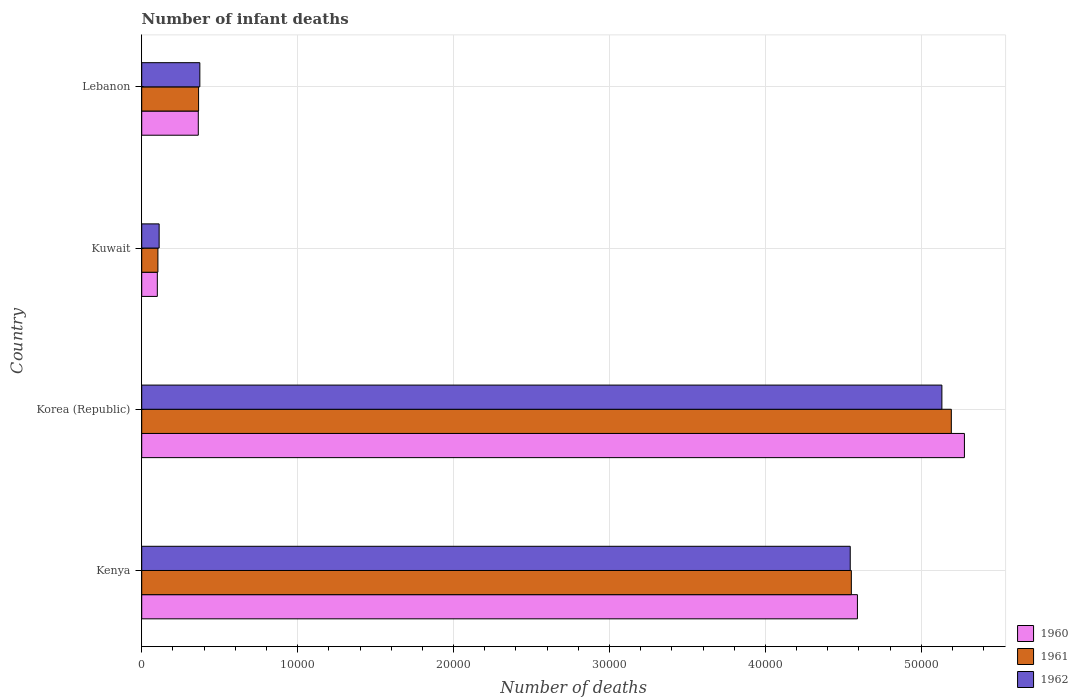How many bars are there on the 2nd tick from the bottom?
Offer a terse response. 3. What is the label of the 2nd group of bars from the top?
Make the answer very short. Kuwait. In how many cases, is the number of bars for a given country not equal to the number of legend labels?
Your answer should be compact. 0. What is the number of infant deaths in 1962 in Korea (Republic)?
Provide a short and direct response. 5.13e+04. Across all countries, what is the maximum number of infant deaths in 1960?
Your answer should be compact. 5.28e+04. Across all countries, what is the minimum number of infant deaths in 1962?
Offer a terse response. 1117. In which country was the number of infant deaths in 1962 minimum?
Give a very brief answer. Kuwait. What is the total number of infant deaths in 1962 in the graph?
Your response must be concise. 1.02e+05. What is the difference between the number of infant deaths in 1960 in Kenya and that in Kuwait?
Your answer should be very brief. 4.49e+04. What is the difference between the number of infant deaths in 1961 in Kuwait and the number of infant deaths in 1960 in Lebanon?
Keep it short and to the point. -2590. What is the average number of infant deaths in 1960 per country?
Make the answer very short. 2.58e+04. What is the difference between the number of infant deaths in 1960 and number of infant deaths in 1961 in Korea (Republic)?
Your answer should be very brief. 840. What is the ratio of the number of infant deaths in 1960 in Kuwait to that in Lebanon?
Provide a succinct answer. 0.28. What is the difference between the highest and the second highest number of infant deaths in 1960?
Provide a short and direct response. 6862. What is the difference between the highest and the lowest number of infant deaths in 1960?
Give a very brief answer. 5.18e+04. In how many countries, is the number of infant deaths in 1962 greater than the average number of infant deaths in 1962 taken over all countries?
Ensure brevity in your answer.  2. How many bars are there?
Keep it short and to the point. 12. How many countries are there in the graph?
Make the answer very short. 4. Are the values on the major ticks of X-axis written in scientific E-notation?
Make the answer very short. No. Does the graph contain grids?
Give a very brief answer. Yes. How are the legend labels stacked?
Offer a very short reply. Vertical. What is the title of the graph?
Provide a succinct answer. Number of infant deaths. What is the label or title of the X-axis?
Provide a succinct answer. Number of deaths. What is the Number of deaths in 1960 in Kenya?
Offer a very short reply. 4.59e+04. What is the Number of deaths of 1961 in Kenya?
Offer a very short reply. 4.55e+04. What is the Number of deaths in 1962 in Kenya?
Offer a very short reply. 4.54e+04. What is the Number of deaths of 1960 in Korea (Republic)?
Your answer should be compact. 5.28e+04. What is the Number of deaths of 1961 in Korea (Republic)?
Offer a very short reply. 5.19e+04. What is the Number of deaths in 1962 in Korea (Republic)?
Make the answer very short. 5.13e+04. What is the Number of deaths of 1960 in Kuwait?
Offer a very short reply. 1001. What is the Number of deaths in 1961 in Kuwait?
Your answer should be compact. 1038. What is the Number of deaths of 1962 in Kuwait?
Provide a succinct answer. 1117. What is the Number of deaths of 1960 in Lebanon?
Make the answer very short. 3628. What is the Number of deaths of 1961 in Lebanon?
Provide a short and direct response. 3646. What is the Number of deaths in 1962 in Lebanon?
Your response must be concise. 3728. Across all countries, what is the maximum Number of deaths in 1960?
Make the answer very short. 5.28e+04. Across all countries, what is the maximum Number of deaths of 1961?
Provide a succinct answer. 5.19e+04. Across all countries, what is the maximum Number of deaths of 1962?
Ensure brevity in your answer.  5.13e+04. Across all countries, what is the minimum Number of deaths of 1960?
Make the answer very short. 1001. Across all countries, what is the minimum Number of deaths of 1961?
Give a very brief answer. 1038. Across all countries, what is the minimum Number of deaths in 1962?
Your answer should be very brief. 1117. What is the total Number of deaths of 1960 in the graph?
Your answer should be very brief. 1.03e+05. What is the total Number of deaths of 1961 in the graph?
Provide a succinct answer. 1.02e+05. What is the total Number of deaths in 1962 in the graph?
Provide a succinct answer. 1.02e+05. What is the difference between the Number of deaths of 1960 in Kenya and that in Korea (Republic)?
Your answer should be very brief. -6862. What is the difference between the Number of deaths of 1961 in Kenya and that in Korea (Republic)?
Ensure brevity in your answer.  -6412. What is the difference between the Number of deaths in 1962 in Kenya and that in Korea (Republic)?
Your response must be concise. -5878. What is the difference between the Number of deaths of 1960 in Kenya and that in Kuwait?
Your response must be concise. 4.49e+04. What is the difference between the Number of deaths of 1961 in Kenya and that in Kuwait?
Ensure brevity in your answer.  4.45e+04. What is the difference between the Number of deaths in 1962 in Kenya and that in Kuwait?
Give a very brief answer. 4.43e+04. What is the difference between the Number of deaths of 1960 in Kenya and that in Lebanon?
Provide a succinct answer. 4.23e+04. What is the difference between the Number of deaths in 1961 in Kenya and that in Lebanon?
Your answer should be compact. 4.19e+04. What is the difference between the Number of deaths in 1962 in Kenya and that in Lebanon?
Make the answer very short. 4.17e+04. What is the difference between the Number of deaths of 1960 in Korea (Republic) and that in Kuwait?
Ensure brevity in your answer.  5.18e+04. What is the difference between the Number of deaths of 1961 in Korea (Republic) and that in Kuwait?
Ensure brevity in your answer.  5.09e+04. What is the difference between the Number of deaths in 1962 in Korea (Republic) and that in Kuwait?
Offer a terse response. 5.02e+04. What is the difference between the Number of deaths of 1960 in Korea (Republic) and that in Lebanon?
Your response must be concise. 4.91e+04. What is the difference between the Number of deaths of 1961 in Korea (Republic) and that in Lebanon?
Offer a terse response. 4.83e+04. What is the difference between the Number of deaths in 1962 in Korea (Republic) and that in Lebanon?
Your answer should be compact. 4.76e+04. What is the difference between the Number of deaths in 1960 in Kuwait and that in Lebanon?
Offer a very short reply. -2627. What is the difference between the Number of deaths in 1961 in Kuwait and that in Lebanon?
Keep it short and to the point. -2608. What is the difference between the Number of deaths of 1962 in Kuwait and that in Lebanon?
Keep it short and to the point. -2611. What is the difference between the Number of deaths in 1960 in Kenya and the Number of deaths in 1961 in Korea (Republic)?
Provide a short and direct response. -6022. What is the difference between the Number of deaths in 1960 in Kenya and the Number of deaths in 1962 in Korea (Republic)?
Your response must be concise. -5417. What is the difference between the Number of deaths of 1961 in Kenya and the Number of deaths of 1962 in Korea (Republic)?
Offer a terse response. -5807. What is the difference between the Number of deaths in 1960 in Kenya and the Number of deaths in 1961 in Kuwait?
Keep it short and to the point. 4.49e+04. What is the difference between the Number of deaths in 1960 in Kenya and the Number of deaths in 1962 in Kuwait?
Your answer should be compact. 4.48e+04. What is the difference between the Number of deaths of 1961 in Kenya and the Number of deaths of 1962 in Kuwait?
Your answer should be compact. 4.44e+04. What is the difference between the Number of deaths of 1960 in Kenya and the Number of deaths of 1961 in Lebanon?
Offer a terse response. 4.23e+04. What is the difference between the Number of deaths in 1960 in Kenya and the Number of deaths in 1962 in Lebanon?
Keep it short and to the point. 4.22e+04. What is the difference between the Number of deaths of 1961 in Kenya and the Number of deaths of 1962 in Lebanon?
Ensure brevity in your answer.  4.18e+04. What is the difference between the Number of deaths in 1960 in Korea (Republic) and the Number of deaths in 1961 in Kuwait?
Offer a terse response. 5.17e+04. What is the difference between the Number of deaths of 1960 in Korea (Republic) and the Number of deaths of 1962 in Kuwait?
Make the answer very short. 5.16e+04. What is the difference between the Number of deaths of 1961 in Korea (Republic) and the Number of deaths of 1962 in Kuwait?
Your response must be concise. 5.08e+04. What is the difference between the Number of deaths of 1960 in Korea (Republic) and the Number of deaths of 1961 in Lebanon?
Provide a succinct answer. 4.91e+04. What is the difference between the Number of deaths of 1960 in Korea (Republic) and the Number of deaths of 1962 in Lebanon?
Offer a very short reply. 4.90e+04. What is the difference between the Number of deaths of 1961 in Korea (Republic) and the Number of deaths of 1962 in Lebanon?
Your answer should be very brief. 4.82e+04. What is the difference between the Number of deaths in 1960 in Kuwait and the Number of deaths in 1961 in Lebanon?
Your answer should be compact. -2645. What is the difference between the Number of deaths in 1960 in Kuwait and the Number of deaths in 1962 in Lebanon?
Provide a succinct answer. -2727. What is the difference between the Number of deaths in 1961 in Kuwait and the Number of deaths in 1962 in Lebanon?
Offer a terse response. -2690. What is the average Number of deaths in 1960 per country?
Offer a terse response. 2.58e+04. What is the average Number of deaths of 1961 per country?
Provide a succinct answer. 2.55e+04. What is the average Number of deaths of 1962 per country?
Make the answer very short. 2.54e+04. What is the difference between the Number of deaths in 1960 and Number of deaths in 1961 in Kenya?
Make the answer very short. 390. What is the difference between the Number of deaths in 1960 and Number of deaths in 1962 in Kenya?
Provide a short and direct response. 461. What is the difference between the Number of deaths in 1961 and Number of deaths in 1962 in Kenya?
Give a very brief answer. 71. What is the difference between the Number of deaths of 1960 and Number of deaths of 1961 in Korea (Republic)?
Your response must be concise. 840. What is the difference between the Number of deaths of 1960 and Number of deaths of 1962 in Korea (Republic)?
Give a very brief answer. 1445. What is the difference between the Number of deaths of 1961 and Number of deaths of 1962 in Korea (Republic)?
Provide a short and direct response. 605. What is the difference between the Number of deaths of 1960 and Number of deaths of 1961 in Kuwait?
Give a very brief answer. -37. What is the difference between the Number of deaths of 1960 and Number of deaths of 1962 in Kuwait?
Make the answer very short. -116. What is the difference between the Number of deaths of 1961 and Number of deaths of 1962 in Kuwait?
Your answer should be compact. -79. What is the difference between the Number of deaths in 1960 and Number of deaths in 1961 in Lebanon?
Your answer should be very brief. -18. What is the difference between the Number of deaths in 1960 and Number of deaths in 1962 in Lebanon?
Provide a succinct answer. -100. What is the difference between the Number of deaths of 1961 and Number of deaths of 1962 in Lebanon?
Offer a terse response. -82. What is the ratio of the Number of deaths in 1960 in Kenya to that in Korea (Republic)?
Ensure brevity in your answer.  0.87. What is the ratio of the Number of deaths in 1961 in Kenya to that in Korea (Republic)?
Provide a succinct answer. 0.88. What is the ratio of the Number of deaths in 1962 in Kenya to that in Korea (Republic)?
Make the answer very short. 0.89. What is the ratio of the Number of deaths of 1960 in Kenya to that in Kuwait?
Offer a terse response. 45.86. What is the ratio of the Number of deaths in 1961 in Kenya to that in Kuwait?
Your answer should be compact. 43.85. What is the ratio of the Number of deaths in 1962 in Kenya to that in Kuwait?
Give a very brief answer. 40.68. What is the ratio of the Number of deaths of 1960 in Kenya to that in Lebanon?
Offer a very short reply. 12.65. What is the ratio of the Number of deaths in 1961 in Kenya to that in Lebanon?
Offer a very short reply. 12.48. What is the ratio of the Number of deaths of 1962 in Kenya to that in Lebanon?
Provide a succinct answer. 12.19. What is the ratio of the Number of deaths of 1960 in Korea (Republic) to that in Kuwait?
Offer a very short reply. 52.71. What is the ratio of the Number of deaths of 1961 in Korea (Republic) to that in Kuwait?
Provide a succinct answer. 50.02. What is the ratio of the Number of deaths in 1962 in Korea (Republic) to that in Kuwait?
Ensure brevity in your answer.  45.94. What is the ratio of the Number of deaths of 1960 in Korea (Republic) to that in Lebanon?
Provide a short and direct response. 14.54. What is the ratio of the Number of deaths of 1961 in Korea (Republic) to that in Lebanon?
Offer a very short reply. 14.24. What is the ratio of the Number of deaths in 1962 in Korea (Republic) to that in Lebanon?
Give a very brief answer. 13.77. What is the ratio of the Number of deaths of 1960 in Kuwait to that in Lebanon?
Your answer should be very brief. 0.28. What is the ratio of the Number of deaths of 1961 in Kuwait to that in Lebanon?
Keep it short and to the point. 0.28. What is the ratio of the Number of deaths of 1962 in Kuwait to that in Lebanon?
Ensure brevity in your answer.  0.3. What is the difference between the highest and the second highest Number of deaths of 1960?
Your answer should be very brief. 6862. What is the difference between the highest and the second highest Number of deaths of 1961?
Offer a very short reply. 6412. What is the difference between the highest and the second highest Number of deaths of 1962?
Provide a succinct answer. 5878. What is the difference between the highest and the lowest Number of deaths of 1960?
Ensure brevity in your answer.  5.18e+04. What is the difference between the highest and the lowest Number of deaths of 1961?
Make the answer very short. 5.09e+04. What is the difference between the highest and the lowest Number of deaths in 1962?
Your response must be concise. 5.02e+04. 